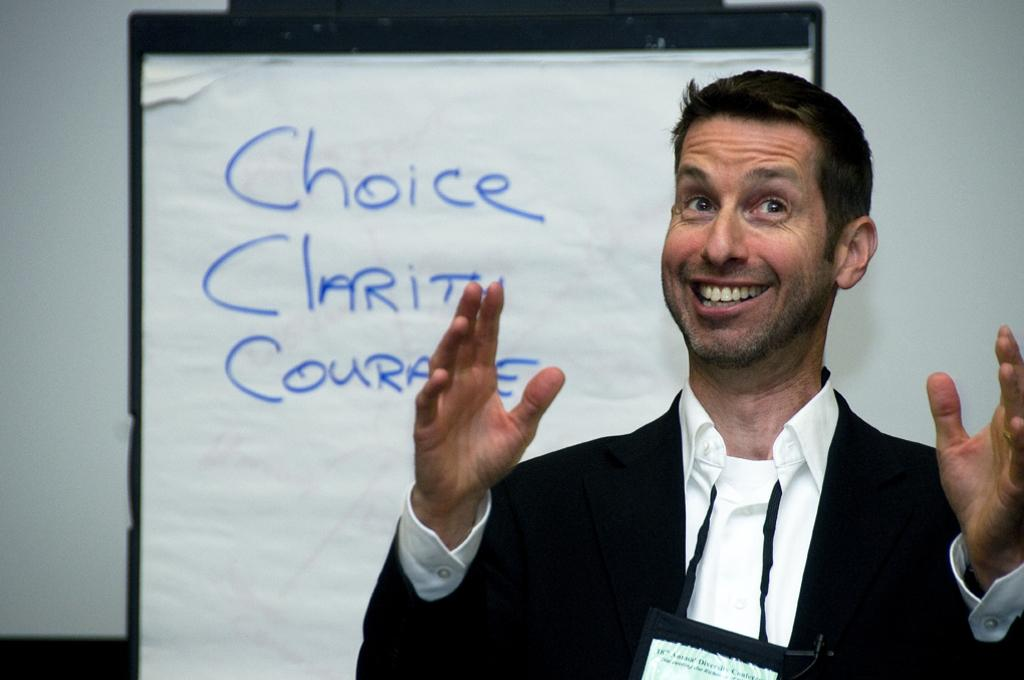What is the main subject of the image? There is a person in the image. What object can be seen behind the person? There is a whiteboard in the image. What type of structure is visible in the background? There is a wall in the image. Can you describe the setting where the image might have been taken? The image may have been taken in a hall, based on the presence of a wall and the possible size of the room. What type of mint can be seen growing on the wall in the image? There is no mint visible in the image; the wall is not described as having any plants or vegetation. 